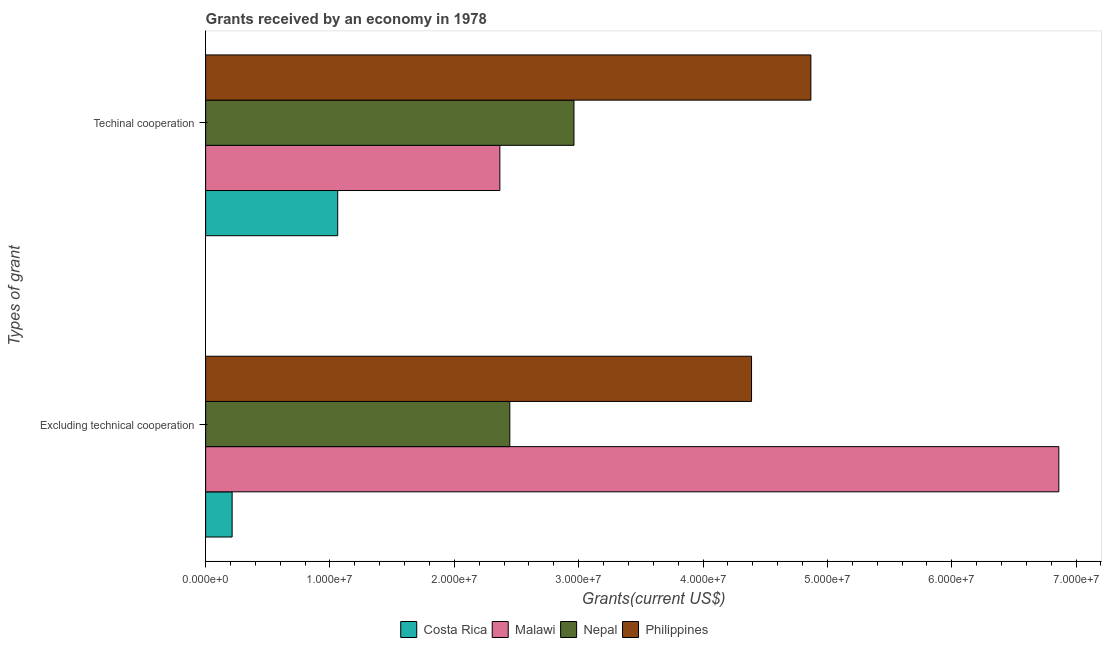Are the number of bars on each tick of the Y-axis equal?
Ensure brevity in your answer.  Yes. How many bars are there on the 1st tick from the bottom?
Your answer should be compact. 4. What is the label of the 2nd group of bars from the top?
Make the answer very short. Excluding technical cooperation. What is the amount of grants received(excluding technical cooperation) in Costa Rica?
Ensure brevity in your answer.  2.13e+06. Across all countries, what is the maximum amount of grants received(including technical cooperation)?
Offer a terse response. 4.87e+07. Across all countries, what is the minimum amount of grants received(including technical cooperation)?
Make the answer very short. 1.06e+07. In which country was the amount of grants received(excluding technical cooperation) maximum?
Ensure brevity in your answer.  Malawi. What is the total amount of grants received(including technical cooperation) in the graph?
Keep it short and to the point. 1.13e+08. What is the difference between the amount of grants received(including technical cooperation) in Malawi and that in Nepal?
Your answer should be very brief. -5.96e+06. What is the difference between the amount of grants received(including technical cooperation) in Philippines and the amount of grants received(excluding technical cooperation) in Costa Rica?
Ensure brevity in your answer.  4.65e+07. What is the average amount of grants received(including technical cooperation) per country?
Provide a short and direct response. 2.81e+07. What is the difference between the amount of grants received(including technical cooperation) and amount of grants received(excluding technical cooperation) in Nepal?
Offer a very short reply. 5.16e+06. What is the ratio of the amount of grants received(excluding technical cooperation) in Philippines to that in Malawi?
Provide a succinct answer. 0.64. Is the amount of grants received(including technical cooperation) in Costa Rica less than that in Malawi?
Your response must be concise. Yes. What does the 2nd bar from the top in Techinal cooperation represents?
Your response must be concise. Nepal. What does the 2nd bar from the bottom in Excluding technical cooperation represents?
Your answer should be very brief. Malawi. How many bars are there?
Provide a succinct answer. 8. Are all the bars in the graph horizontal?
Keep it short and to the point. Yes. How many countries are there in the graph?
Ensure brevity in your answer.  4. Does the graph contain any zero values?
Keep it short and to the point. No. How are the legend labels stacked?
Offer a very short reply. Horizontal. What is the title of the graph?
Your answer should be very brief. Grants received by an economy in 1978. Does "Thailand" appear as one of the legend labels in the graph?
Give a very brief answer. No. What is the label or title of the X-axis?
Your answer should be compact. Grants(current US$). What is the label or title of the Y-axis?
Provide a succinct answer. Types of grant. What is the Grants(current US$) in Costa Rica in Excluding technical cooperation?
Provide a succinct answer. 2.13e+06. What is the Grants(current US$) in Malawi in Excluding technical cooperation?
Your answer should be compact. 6.86e+07. What is the Grants(current US$) of Nepal in Excluding technical cooperation?
Provide a short and direct response. 2.45e+07. What is the Grants(current US$) in Philippines in Excluding technical cooperation?
Give a very brief answer. 4.39e+07. What is the Grants(current US$) in Costa Rica in Techinal cooperation?
Your answer should be compact. 1.06e+07. What is the Grants(current US$) of Malawi in Techinal cooperation?
Provide a succinct answer. 2.37e+07. What is the Grants(current US$) of Nepal in Techinal cooperation?
Keep it short and to the point. 2.96e+07. What is the Grants(current US$) in Philippines in Techinal cooperation?
Make the answer very short. 4.87e+07. Across all Types of grant, what is the maximum Grants(current US$) in Costa Rica?
Your answer should be very brief. 1.06e+07. Across all Types of grant, what is the maximum Grants(current US$) of Malawi?
Give a very brief answer. 6.86e+07. Across all Types of grant, what is the maximum Grants(current US$) in Nepal?
Your response must be concise. 2.96e+07. Across all Types of grant, what is the maximum Grants(current US$) in Philippines?
Your answer should be very brief. 4.87e+07. Across all Types of grant, what is the minimum Grants(current US$) of Costa Rica?
Make the answer very short. 2.13e+06. Across all Types of grant, what is the minimum Grants(current US$) in Malawi?
Ensure brevity in your answer.  2.37e+07. Across all Types of grant, what is the minimum Grants(current US$) in Nepal?
Keep it short and to the point. 2.45e+07. Across all Types of grant, what is the minimum Grants(current US$) in Philippines?
Ensure brevity in your answer.  4.39e+07. What is the total Grants(current US$) of Costa Rica in the graph?
Keep it short and to the point. 1.28e+07. What is the total Grants(current US$) in Malawi in the graph?
Make the answer very short. 9.23e+07. What is the total Grants(current US$) in Nepal in the graph?
Make the answer very short. 5.41e+07. What is the total Grants(current US$) of Philippines in the graph?
Keep it short and to the point. 9.26e+07. What is the difference between the Grants(current US$) of Costa Rica in Excluding technical cooperation and that in Techinal cooperation?
Keep it short and to the point. -8.49e+06. What is the difference between the Grants(current US$) in Malawi in Excluding technical cooperation and that in Techinal cooperation?
Offer a very short reply. 4.50e+07. What is the difference between the Grants(current US$) of Nepal in Excluding technical cooperation and that in Techinal cooperation?
Offer a terse response. -5.16e+06. What is the difference between the Grants(current US$) in Philippines in Excluding technical cooperation and that in Techinal cooperation?
Keep it short and to the point. -4.77e+06. What is the difference between the Grants(current US$) in Costa Rica in Excluding technical cooperation and the Grants(current US$) in Malawi in Techinal cooperation?
Provide a succinct answer. -2.15e+07. What is the difference between the Grants(current US$) of Costa Rica in Excluding technical cooperation and the Grants(current US$) of Nepal in Techinal cooperation?
Your response must be concise. -2.75e+07. What is the difference between the Grants(current US$) in Costa Rica in Excluding technical cooperation and the Grants(current US$) in Philippines in Techinal cooperation?
Your answer should be compact. -4.65e+07. What is the difference between the Grants(current US$) in Malawi in Excluding technical cooperation and the Grants(current US$) in Nepal in Techinal cooperation?
Offer a terse response. 3.90e+07. What is the difference between the Grants(current US$) in Malawi in Excluding technical cooperation and the Grants(current US$) in Philippines in Techinal cooperation?
Your response must be concise. 1.99e+07. What is the difference between the Grants(current US$) in Nepal in Excluding technical cooperation and the Grants(current US$) in Philippines in Techinal cooperation?
Make the answer very short. -2.42e+07. What is the average Grants(current US$) of Costa Rica per Types of grant?
Offer a very short reply. 6.38e+06. What is the average Grants(current US$) in Malawi per Types of grant?
Ensure brevity in your answer.  4.61e+07. What is the average Grants(current US$) in Nepal per Types of grant?
Give a very brief answer. 2.70e+07. What is the average Grants(current US$) in Philippines per Types of grant?
Provide a short and direct response. 4.63e+07. What is the difference between the Grants(current US$) of Costa Rica and Grants(current US$) of Malawi in Excluding technical cooperation?
Your answer should be very brief. -6.65e+07. What is the difference between the Grants(current US$) in Costa Rica and Grants(current US$) in Nepal in Excluding technical cooperation?
Provide a short and direct response. -2.23e+07. What is the difference between the Grants(current US$) of Costa Rica and Grants(current US$) of Philippines in Excluding technical cooperation?
Your answer should be compact. -4.18e+07. What is the difference between the Grants(current US$) in Malawi and Grants(current US$) in Nepal in Excluding technical cooperation?
Offer a very short reply. 4.42e+07. What is the difference between the Grants(current US$) of Malawi and Grants(current US$) of Philippines in Excluding technical cooperation?
Make the answer very short. 2.47e+07. What is the difference between the Grants(current US$) in Nepal and Grants(current US$) in Philippines in Excluding technical cooperation?
Keep it short and to the point. -1.94e+07. What is the difference between the Grants(current US$) of Costa Rica and Grants(current US$) of Malawi in Techinal cooperation?
Your response must be concise. -1.30e+07. What is the difference between the Grants(current US$) of Costa Rica and Grants(current US$) of Nepal in Techinal cooperation?
Provide a succinct answer. -1.90e+07. What is the difference between the Grants(current US$) in Costa Rica and Grants(current US$) in Philippines in Techinal cooperation?
Your response must be concise. -3.80e+07. What is the difference between the Grants(current US$) of Malawi and Grants(current US$) of Nepal in Techinal cooperation?
Offer a terse response. -5.96e+06. What is the difference between the Grants(current US$) of Malawi and Grants(current US$) of Philippines in Techinal cooperation?
Provide a short and direct response. -2.50e+07. What is the difference between the Grants(current US$) in Nepal and Grants(current US$) in Philippines in Techinal cooperation?
Ensure brevity in your answer.  -1.90e+07. What is the ratio of the Grants(current US$) in Costa Rica in Excluding technical cooperation to that in Techinal cooperation?
Your response must be concise. 0.2. What is the ratio of the Grants(current US$) in Malawi in Excluding technical cooperation to that in Techinal cooperation?
Provide a succinct answer. 2.9. What is the ratio of the Grants(current US$) in Nepal in Excluding technical cooperation to that in Techinal cooperation?
Give a very brief answer. 0.83. What is the ratio of the Grants(current US$) in Philippines in Excluding technical cooperation to that in Techinal cooperation?
Provide a short and direct response. 0.9. What is the difference between the highest and the second highest Grants(current US$) in Costa Rica?
Your answer should be very brief. 8.49e+06. What is the difference between the highest and the second highest Grants(current US$) of Malawi?
Your answer should be very brief. 4.50e+07. What is the difference between the highest and the second highest Grants(current US$) of Nepal?
Give a very brief answer. 5.16e+06. What is the difference between the highest and the second highest Grants(current US$) of Philippines?
Provide a short and direct response. 4.77e+06. What is the difference between the highest and the lowest Grants(current US$) in Costa Rica?
Provide a short and direct response. 8.49e+06. What is the difference between the highest and the lowest Grants(current US$) of Malawi?
Offer a terse response. 4.50e+07. What is the difference between the highest and the lowest Grants(current US$) of Nepal?
Your answer should be very brief. 5.16e+06. What is the difference between the highest and the lowest Grants(current US$) in Philippines?
Offer a terse response. 4.77e+06. 